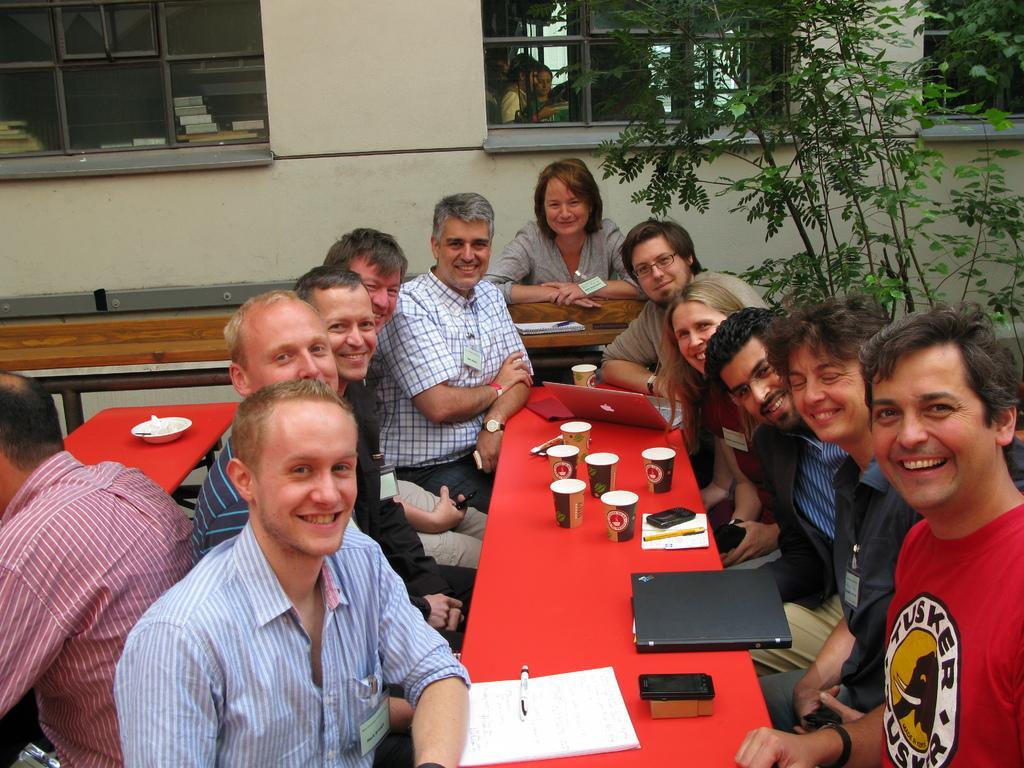Could you give a brief overview of what you see in this image? There are few people sitting on the bench. This is a red table with few glasses,mobile phone,papers,laptop and file placed on it. At background I can see a building with windows,and this is the tree. 